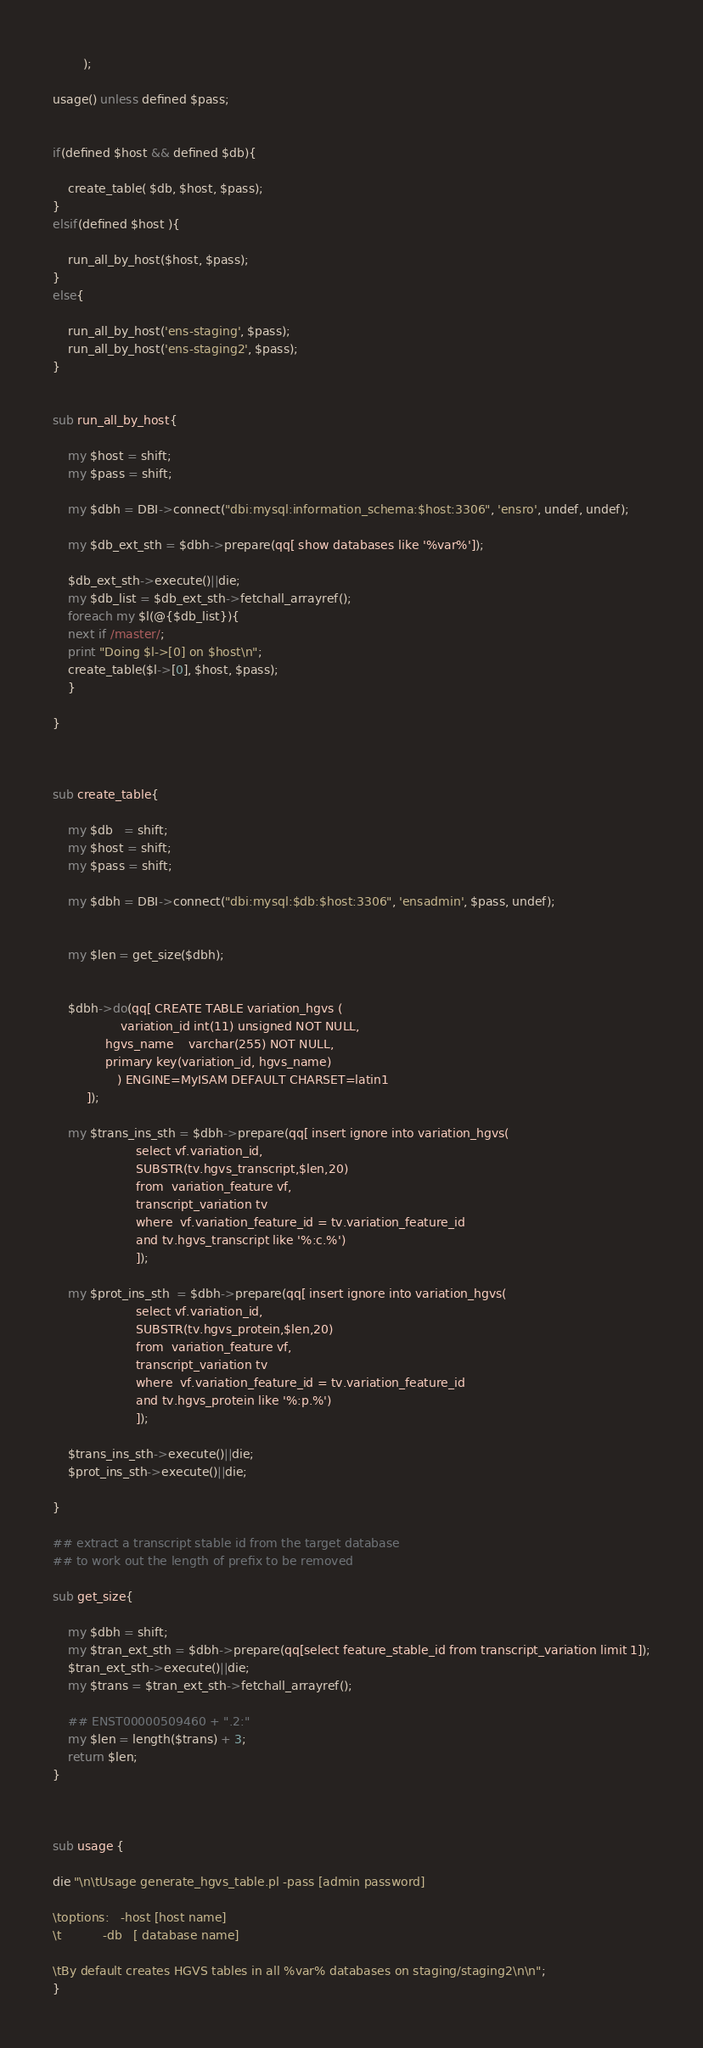Convert code to text. <code><loc_0><loc_0><loc_500><loc_500><_Perl_>	    );

usage() unless defined $pass;


if(defined $host && defined $db){

    create_table( $db, $host, $pass);
}
elsif(defined $host ){

    run_all_by_host($host, $pass);
}
else{

    run_all_by_host('ens-staging', $pass);
    run_all_by_host('ens-staging2', $pass);
}


sub run_all_by_host{

    my $host = shift;
    my $pass = shift;

    my $dbh = DBI->connect("dbi:mysql:information_schema:$host:3306", 'ensro', undef, undef);

    my $db_ext_sth = $dbh->prepare(qq[ show databases like '%var%']);

    $db_ext_sth->execute()||die;
    my $db_list = $db_ext_sth->fetchall_arrayref();
    foreach my $l(@{$db_list}){
	next if /master/;
	print "Doing $l->[0] on $host\n";
	create_table($l->[0], $host, $pass);
    }

}
    


sub create_table{

    my $db   = shift;
    my $host = shift;
    my $pass = shift;

    my $dbh = DBI->connect("dbi:mysql:$db:$host:3306", 'ensadmin', $pass, undef);


    my $len = get_size($dbh);


    $dbh->do(qq[ CREATE TABLE variation_hgvs (
                  variation_id int(11) unsigned NOT NULL,
	          hgvs_name    varchar(255) NOT NULL,
	          primary key(variation_id, hgvs_name)
                 ) ENGINE=MyISAM DEFAULT CHARSET=latin1
		 ]);

    my $trans_ins_sth = $dbh->prepare(qq[ insert ignore into variation_hgvs(
					  select vf.variation_id,
					  SUBSTR(tv.hgvs_transcript,$len,20)
					  from  variation_feature vf,
					  transcript_variation tv
					  where  vf.variation_feature_id = tv.variation_feature_id
					  and tv.hgvs_transcript like '%:c.%')
					  ]);
    
    my $prot_ins_sth  = $dbh->prepare(qq[ insert ignore into variation_hgvs(
					  select vf.variation_id,
					  SUBSTR(tv.hgvs_protein,$len,20)
					  from  variation_feature vf,
					  transcript_variation tv
					  where  vf.variation_feature_id = tv.variation_feature_id
					  and tv.hgvs_protein like '%:p.%')
					  ]);

    $trans_ins_sth->execute()||die;
    $prot_ins_sth->execute()||die;

}

## extract a transcript stable id from the target database 
## to work out the length of prefix to be removed

sub get_size{

    my $dbh = shift;
    my $tran_ext_sth = $dbh->prepare(qq[select feature_stable_id from transcript_variation limit 1]);
    $tran_ext_sth->execute()||die;
    my $trans = $tran_ext_sth->fetchall_arrayref();

    ## ENST00000509460 + ".2:"
    my $len = length($trans) + 3;
    return $len;
}



sub usage {

die "\n\tUsage generate_hgvs_table.pl -pass [admin password]

\toptions:   -host [host name]
\t           -db   [ database name]

\tBy default creates HGVS tables in all %var% databases on staging/staging2\n\n";
}     
</code> 